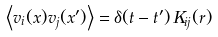<formula> <loc_0><loc_0><loc_500><loc_500>\left \langle v _ { i } ( x ) v _ { j } ( x ^ { \prime } ) \right \rangle = \delta ( t - t ^ { \prime } ) \, K _ { i j } ( { r } )</formula> 